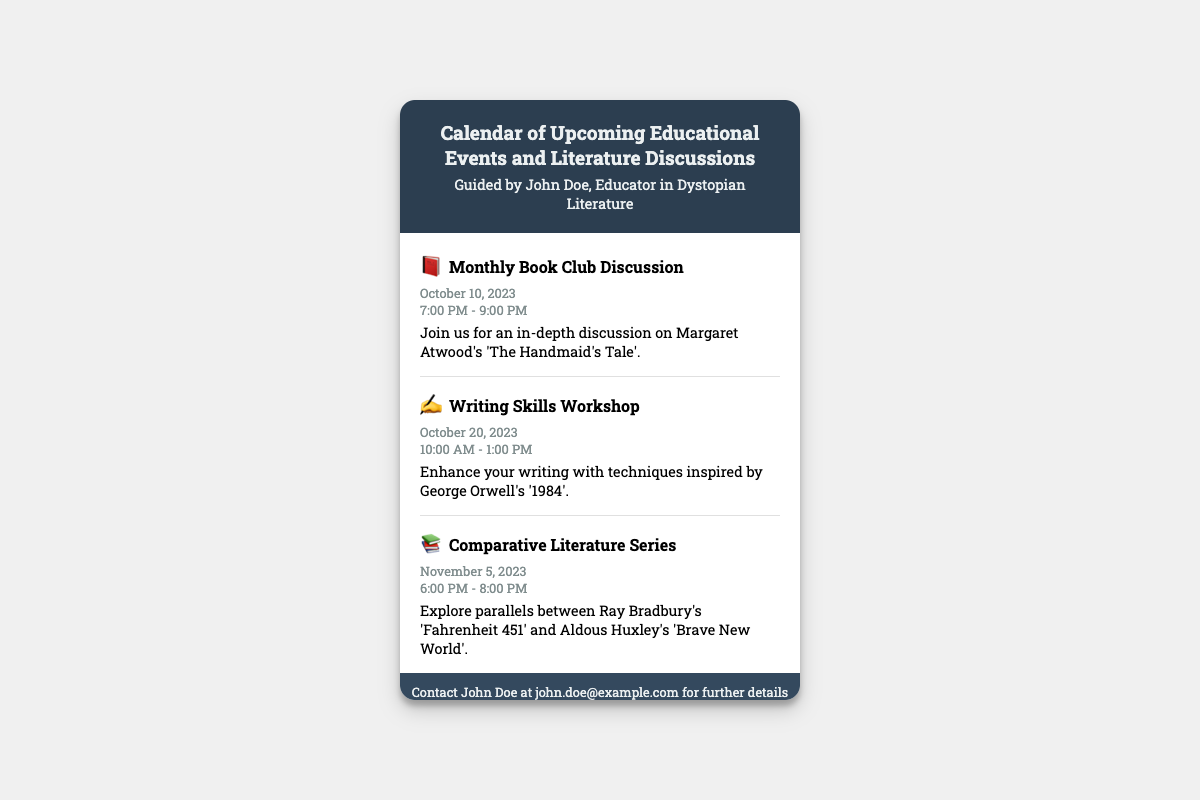What is the title of the first event? The title of the first event is directly stated under the event details section of the document.
Answer: Monthly Book Club Discussion When is the Writing Skills Workshop taking place? The date for the Writing Skills Workshop is mentioned in the event's date section.
Answer: October 20, 2023 Who is the special guest lecturer for the event on November 15, 2023? The document clearly identifies the special guest lecturer in the event details.
Answer: Dr. Emily Larsen What is the theme for the Monthly Book Club Discussion? The theme is noted in the event details of the first event and specifies the book being discussed.
Answer: Margaret Atwood's 'The Handmaid's Tale' How many events are scheduled for October 2023? The document lists events by month, and we need to count the occurrences in October 2023.
Answer: 2 What is the time for the Comparative Literature Series? The time of the Comparative Literature Series is indicated in the event time section of that specific event.
Answer: 6:00 PM - 8:00 PM What is the main focus of the Guest Lecture on November 15, 2023? The main focus is described in the event details of the Guest Lecture event.
Answer: Dystopian themes in modern literature When is the deadline for submitting essays? This information is provided in the event date section related to student submission deadlines.
Answer: December 1, 2023 How can someone get further details about the events? The footer section contains the contact information for inquiries related to the events.
Answer: john.doe@example.com 